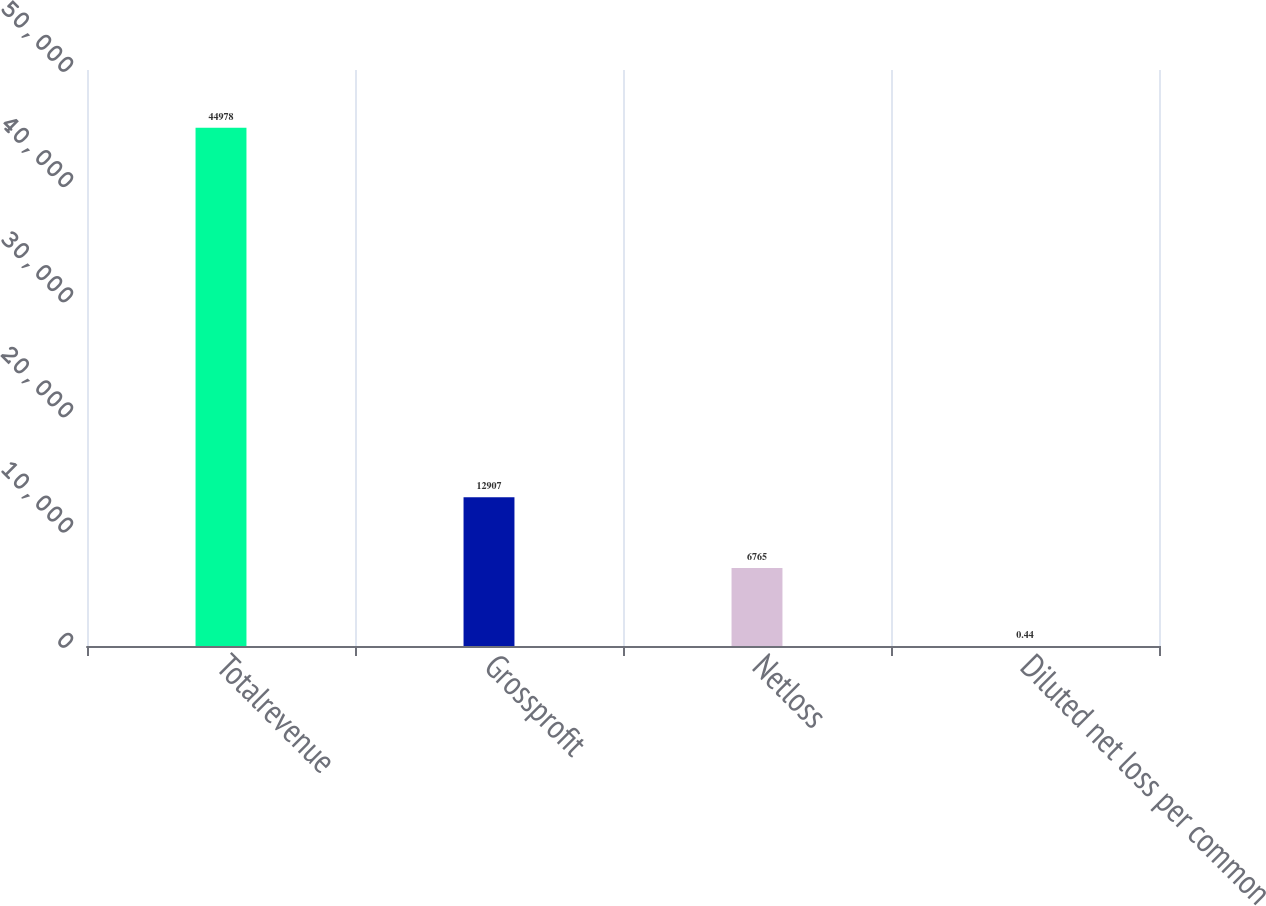<chart> <loc_0><loc_0><loc_500><loc_500><bar_chart><fcel>Totalrevenue<fcel>Grossprofit<fcel>Netloss<fcel>Diluted net loss per common<nl><fcel>44978<fcel>12907<fcel>6765<fcel>0.44<nl></chart> 